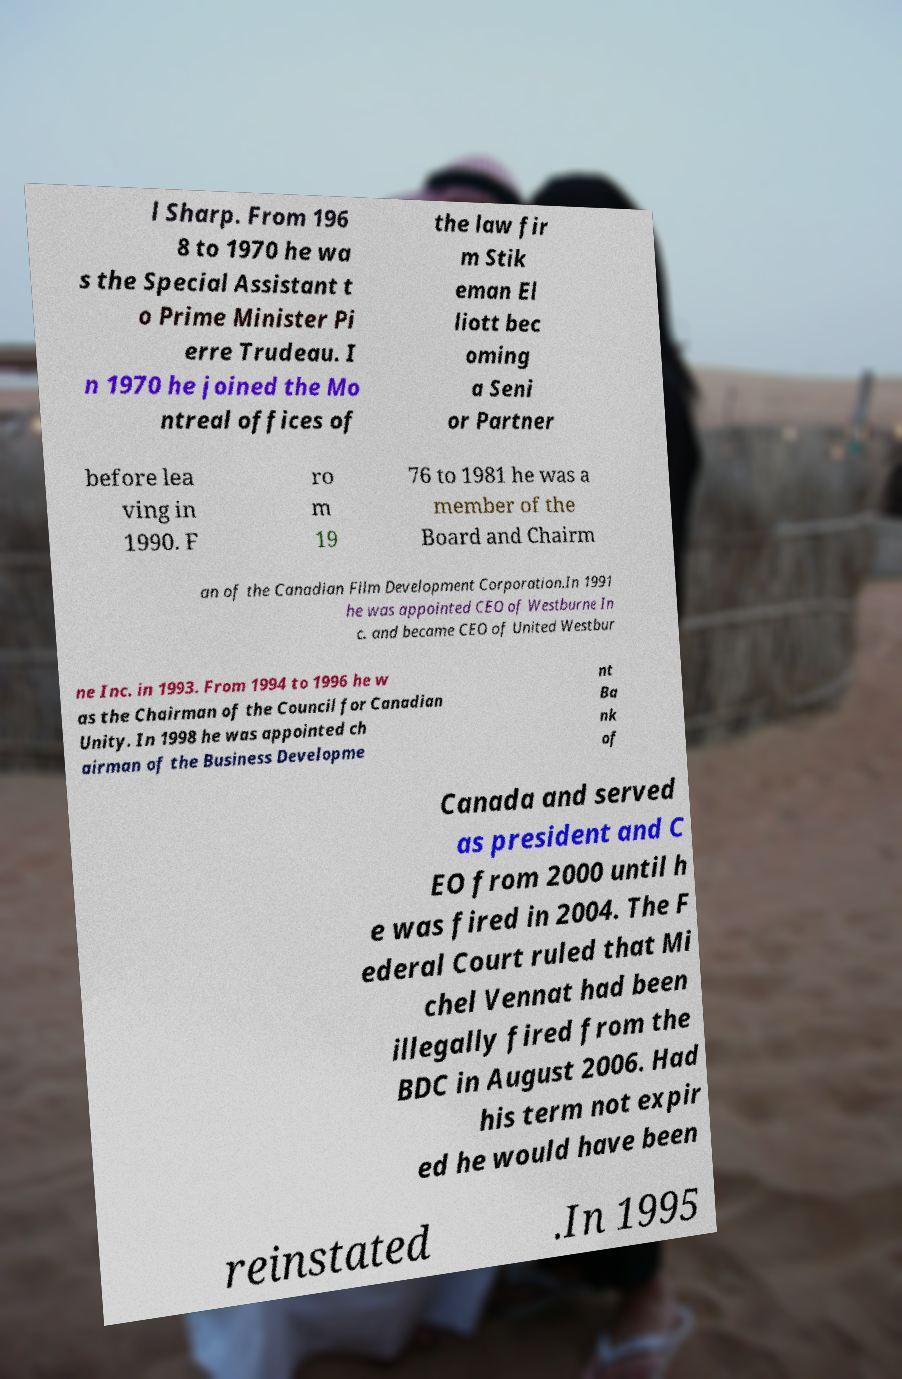Please read and relay the text visible in this image. What does it say? l Sharp. From 196 8 to 1970 he wa s the Special Assistant t o Prime Minister Pi erre Trudeau. I n 1970 he joined the Mo ntreal offices of the law fir m Stik eman El liott bec oming a Seni or Partner before lea ving in 1990. F ro m 19 76 to 1981 he was a member of the Board and Chairm an of the Canadian Film Development Corporation.In 1991 he was appointed CEO of Westburne In c. and became CEO of United Westbur ne Inc. in 1993. From 1994 to 1996 he w as the Chairman of the Council for Canadian Unity. In 1998 he was appointed ch airman of the Business Developme nt Ba nk of Canada and served as president and C EO from 2000 until h e was fired in 2004. The F ederal Court ruled that Mi chel Vennat had been illegally fired from the BDC in August 2006. Had his term not expir ed he would have been reinstated .In 1995 